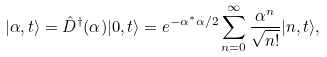<formula> <loc_0><loc_0><loc_500><loc_500>| \alpha , t \rangle = \hat { D } ^ { \dagger } ( \alpha ) | 0 , t \rangle = e ^ { - \alpha ^ { * } \alpha / 2 } \sum _ { n = 0 } ^ { \infty } \frac { \alpha ^ { n } } { \sqrt { n ! } } | n , t \rangle ,</formula> 